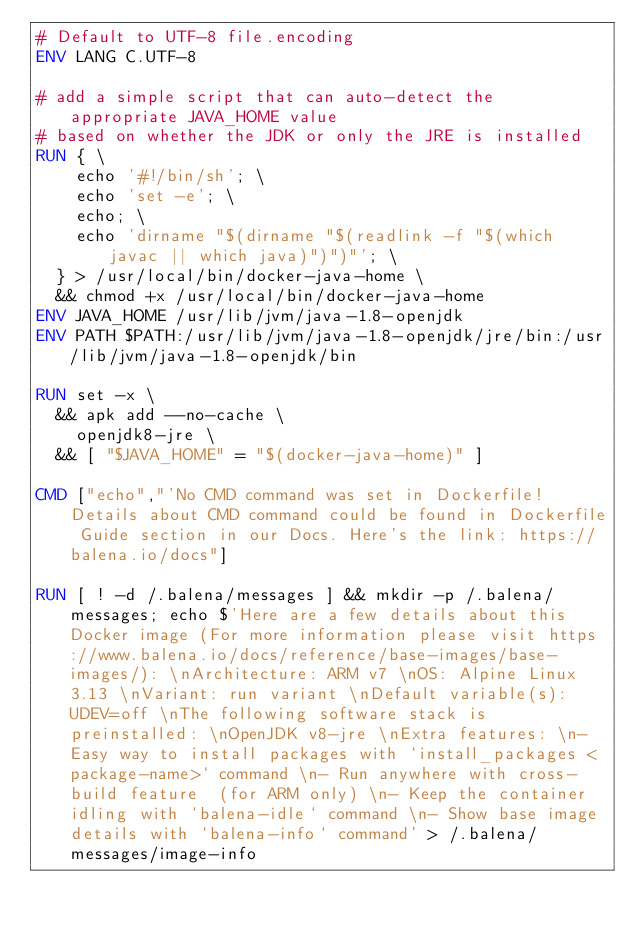Convert code to text. <code><loc_0><loc_0><loc_500><loc_500><_Dockerfile_># Default to UTF-8 file.encoding
ENV LANG C.UTF-8

# add a simple script that can auto-detect the appropriate JAVA_HOME value
# based on whether the JDK or only the JRE is installed
RUN { \
		echo '#!/bin/sh'; \
		echo 'set -e'; \
		echo; \
		echo 'dirname "$(dirname "$(readlink -f "$(which javac || which java)")")"'; \
	} > /usr/local/bin/docker-java-home \
	&& chmod +x /usr/local/bin/docker-java-home
ENV JAVA_HOME /usr/lib/jvm/java-1.8-openjdk
ENV PATH $PATH:/usr/lib/jvm/java-1.8-openjdk/jre/bin:/usr/lib/jvm/java-1.8-openjdk/bin

RUN set -x \
	&& apk add --no-cache \
		openjdk8-jre \
	&& [ "$JAVA_HOME" = "$(docker-java-home)" ]

CMD ["echo","'No CMD command was set in Dockerfile! Details about CMD command could be found in Dockerfile Guide section in our Docs. Here's the link: https://balena.io/docs"]

RUN [ ! -d /.balena/messages ] && mkdir -p /.balena/messages; echo $'Here are a few details about this Docker image (For more information please visit https://www.balena.io/docs/reference/base-images/base-images/): \nArchitecture: ARM v7 \nOS: Alpine Linux 3.13 \nVariant: run variant \nDefault variable(s): UDEV=off \nThe following software stack is preinstalled: \nOpenJDK v8-jre \nExtra features: \n- Easy way to install packages with `install_packages <package-name>` command \n- Run anywhere with cross-build feature  (for ARM only) \n- Keep the container idling with `balena-idle` command \n- Show base image details with `balena-info` command' > /.balena/messages/image-info</code> 